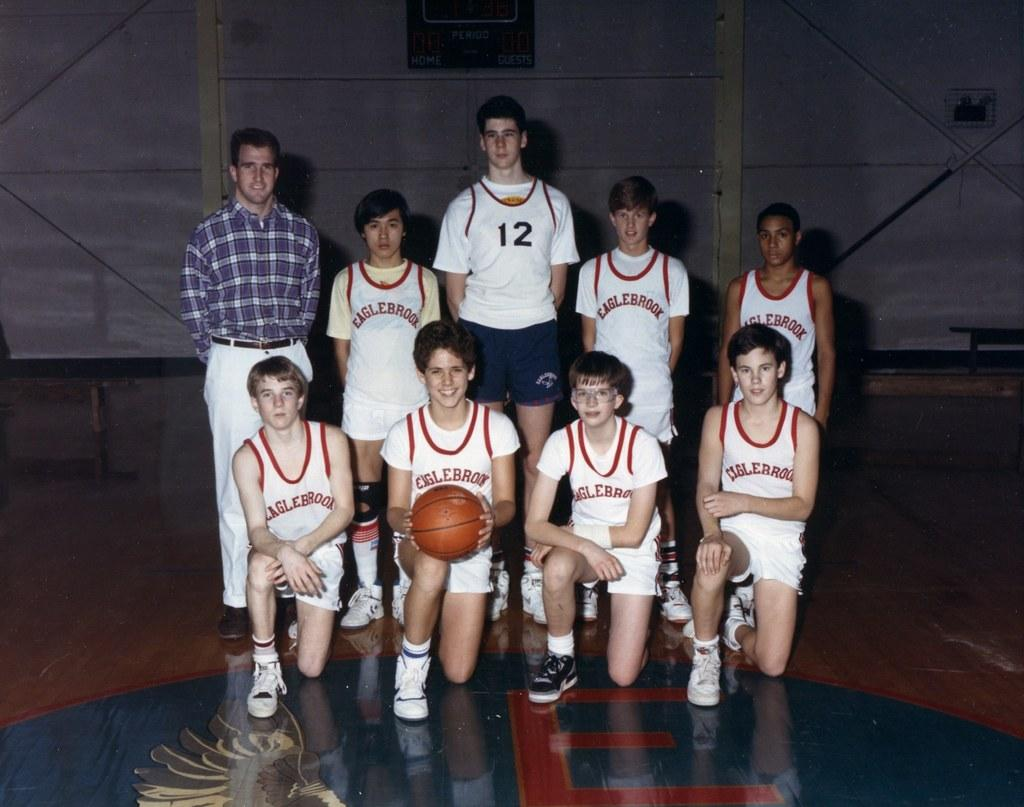<image>
Write a terse but informative summary of the picture. A group of basketball players with the back middle one with a 12 on front. 